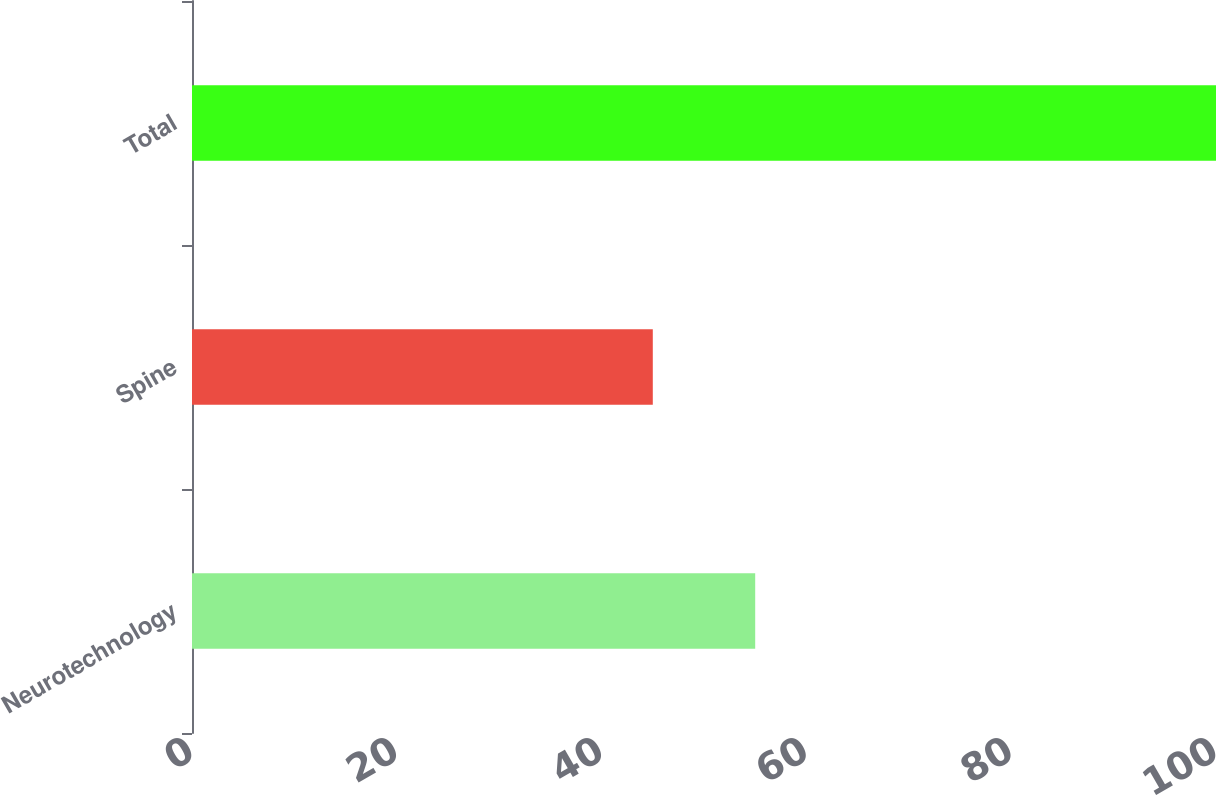Convert chart. <chart><loc_0><loc_0><loc_500><loc_500><bar_chart><fcel>Neurotechnology<fcel>Spine<fcel>Total<nl><fcel>55<fcel>45<fcel>100<nl></chart> 